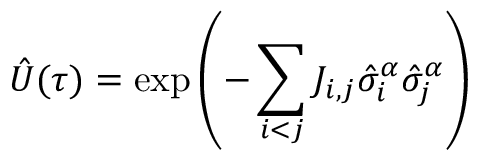<formula> <loc_0><loc_0><loc_500><loc_500>\hat { U } ( \tau ) = \exp \left ( - \sum _ { i < j } J _ { i , j } \hat { \sigma } _ { i } ^ { \alpha } \hat { \sigma } _ { j } ^ { \alpha } \right )</formula> 